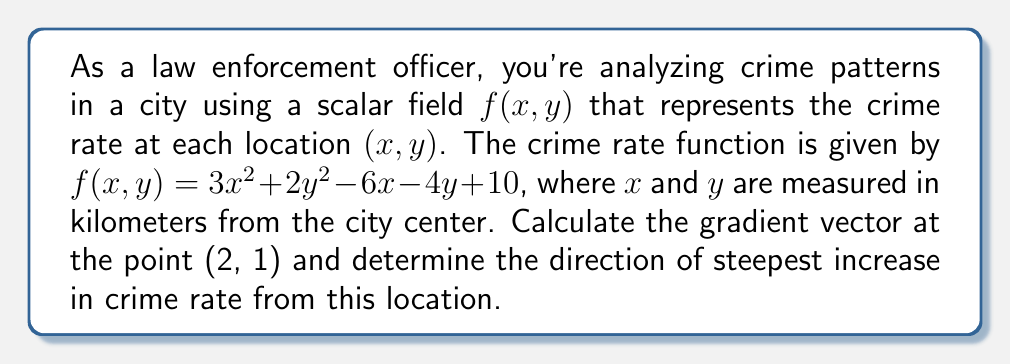Give your solution to this math problem. 1) To find the gradient vector, we need to calculate the partial derivatives of $f(x,y)$ with respect to $x$ and $y$:

   $\frac{\partial f}{\partial x} = 6x - 6$
   $\frac{\partial f}{\partial y} = 4y - 4$

2) The gradient vector is defined as:
   
   $\nabla f = \left(\frac{\partial f}{\partial x}, \frac{\partial f}{\partial y}\right)$

3) Evaluate the gradient at the point (2, 1):

   $\frac{\partial f}{\partial x}|_{(2,1)} = 6(2) - 6 = 6$
   $\frac{\partial f}{\partial y}|_{(2,1)} = 4(1) - 4 = 0$

4) Therefore, the gradient vector at (2, 1) is:

   $\nabla f(2,1) = (6, 0)$

5) The direction of steepest increase is given by the direction of the gradient vector. In this case, it points directly along the positive x-axis.

6) To express this as a unit vector (for direction only), we normalize the gradient:

   $\frac{\nabla f(2,1)}{|\nabla f(2,1)|} = \frac{(6, 0)}{\sqrt{6^2 + 0^2}} = (1, 0)$
Answer: $(1, 0)$ 